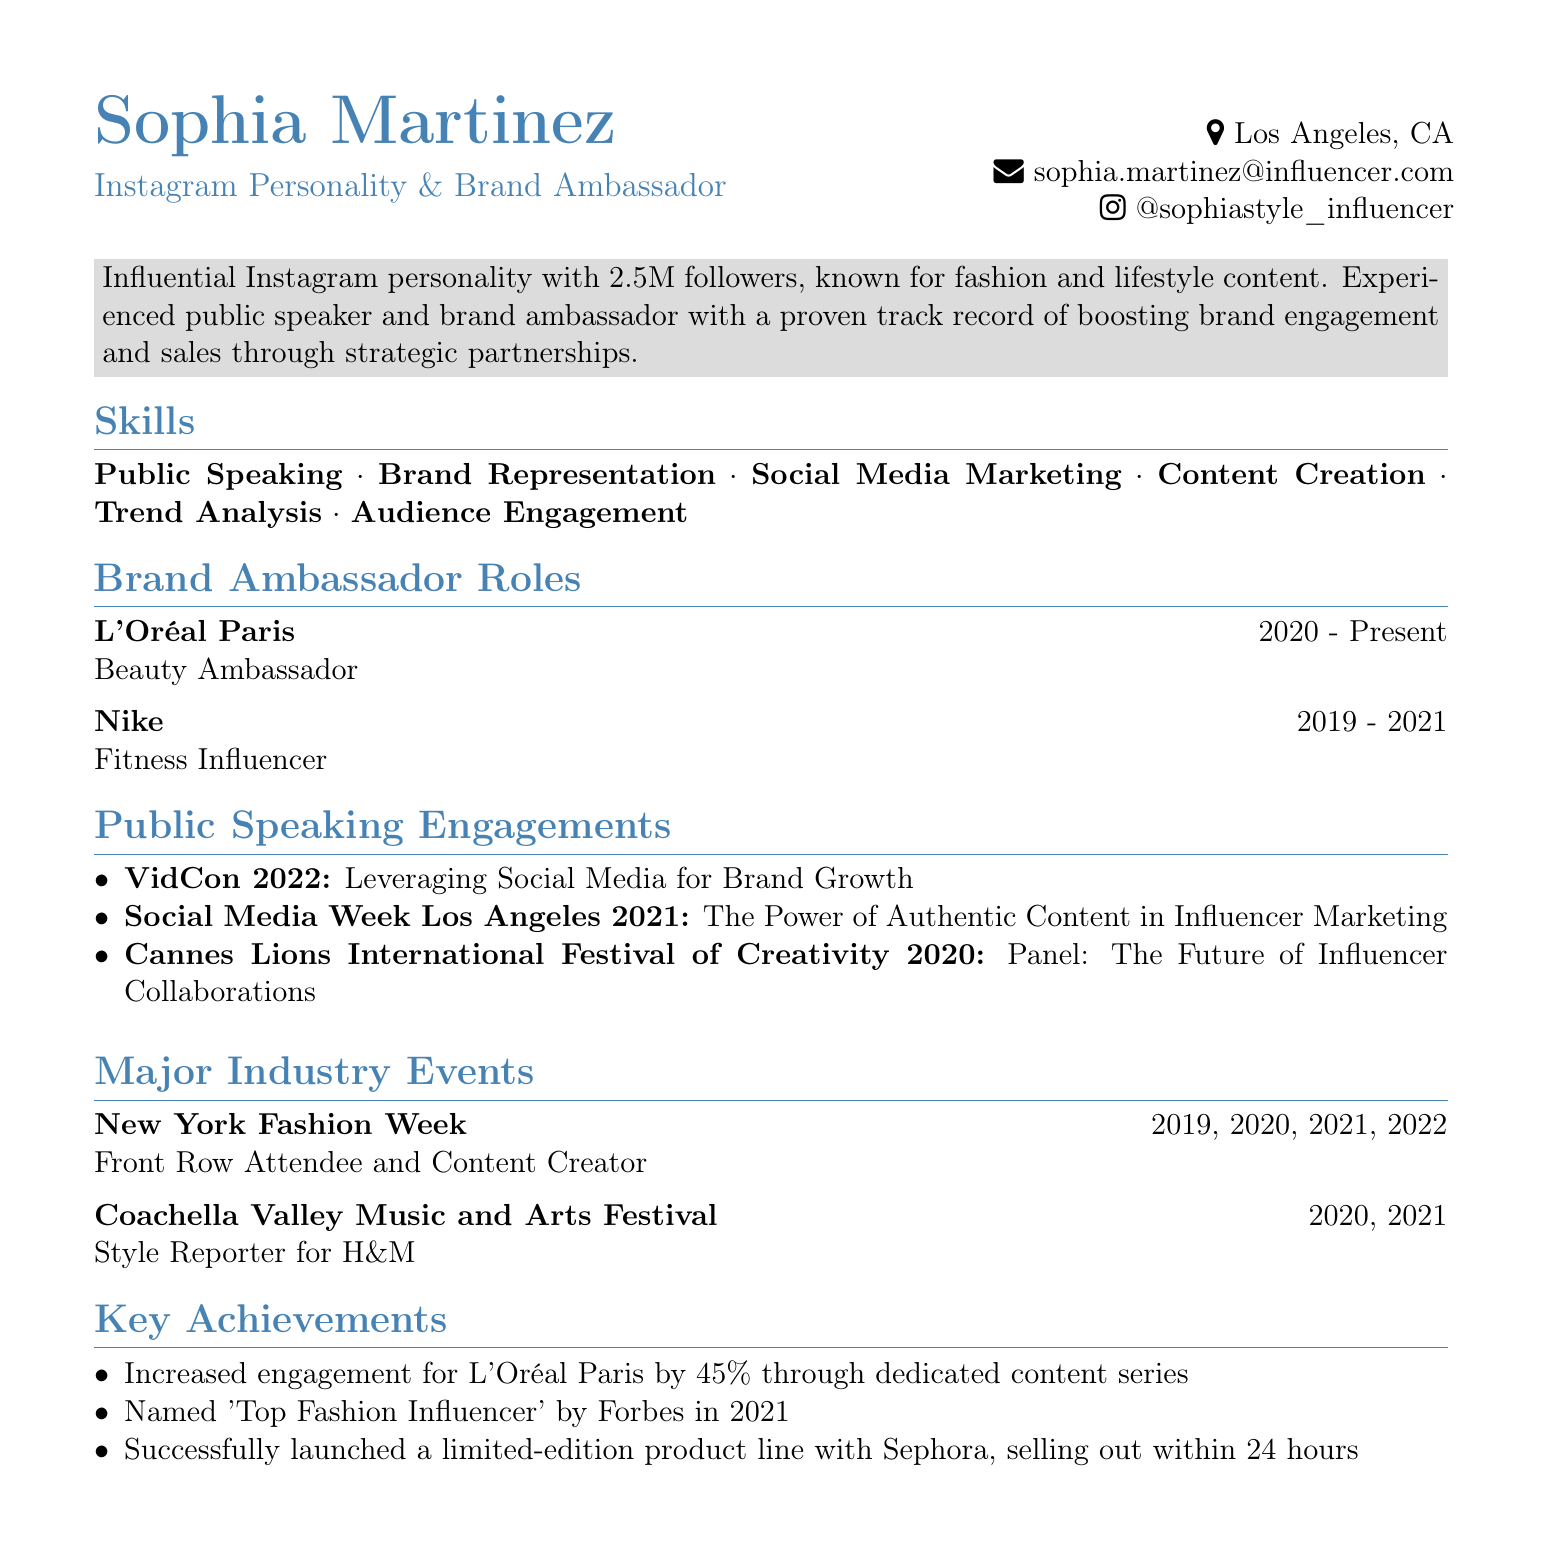what is Sophia Martinez's location? The location listed in the document under personal information is Los Angeles, CA.
Answer: Los Angeles, CA how many followers does Sophia Martinez have? The document states that Sophia Martinez has 2.5M followers on Instagram.
Answer: 2.5M which brand did Sophia work with as a Beauty Ambassador? The document lists L'Oréal Paris as a brand for which she served as a Beauty Ambassador.
Answer: L'Oréal Paris in which year did Sophia speak at VidCon? The document indicates that Sophia spoke at VidCon in 2022.
Answer: 2022 what achievement is associated with L'Oréal Paris? The document mentions that engagement for L'Oréal Paris was increased by 45% through a dedicated content series.
Answer: 45% which major event did Sophia attend as a Style Reporter for H&M? The document states that she was a Style Reporter for H&M at the Coachella Valley Music and Arts Festival.
Answer: Coachella Valley Music and Arts Festival how many years did Sophia represent Nike as a Fitness Influencer? According to the document, she represented Nike from 2019 to 2021, which is a duration of 2 years.
Answer: 2 years what was the topic of the panel Sophia spoke on at Cannes Lions International Festival of Creativity? The document lists the topic of the panel as "The Future of Influencer Collaborations."
Answer: The Future of Influencer Collaborations 